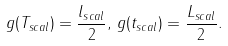Convert formula to latex. <formula><loc_0><loc_0><loc_500><loc_500>g ( T _ { s c a l } ) = \frac { l _ { s c a l } } { 2 } , \, g ( t _ { s c a l } ) = \frac { L _ { s c a l } } { 2 } .</formula> 